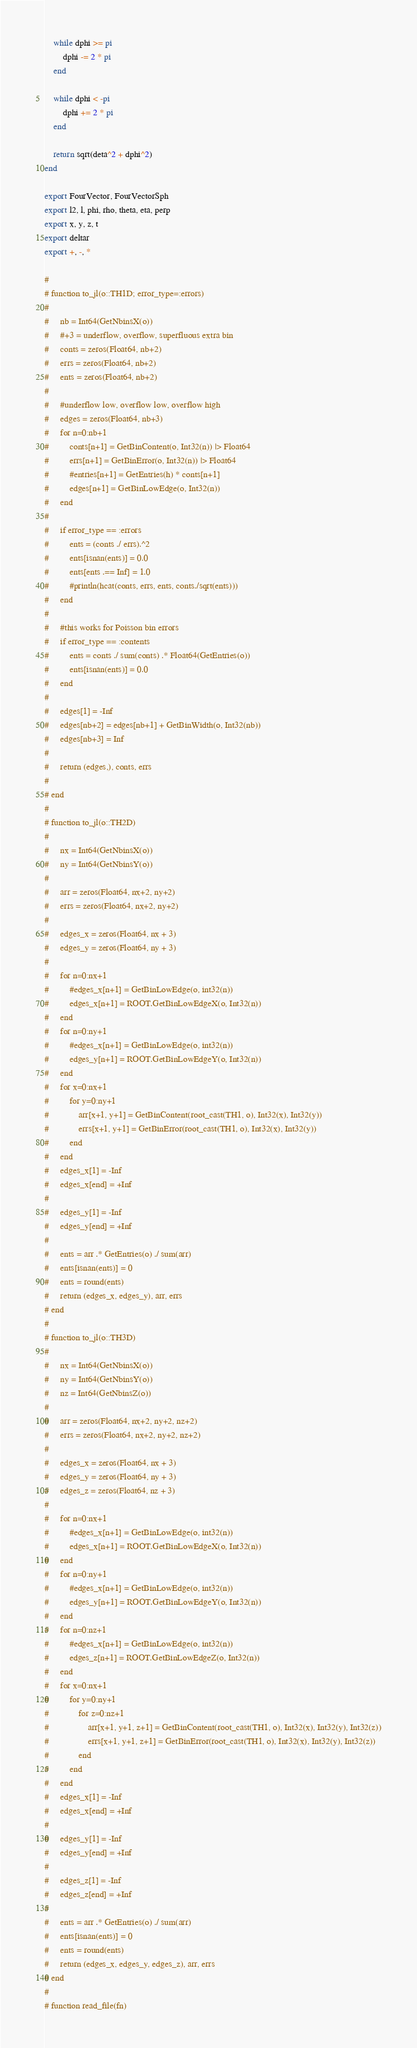Convert code to text. <code><loc_0><loc_0><loc_500><loc_500><_Julia_>    while dphi >= pi
        dphi -= 2 * pi
    end
    
    while dphi < -pi 
        dphi += 2 * pi
    end

    return sqrt(deta^2 + dphi^2)
end

export FourVector, FourVectorSph
export l2, l, phi, rho, theta, eta, perp
export x, y, z, t
export deltar
export +, -, *

# 
# function to_jl(o::TH1D; error_type=:errors)
#     
#     nb = Int64(GetNbinsX(o))
#     #+3 = underflow, overflow, superfluous extra bin
#     conts = zeros(Float64, nb+2)
#     errs = zeros(Float64, nb+2)
#     ents = zeros(Float64, nb+2)
# 
#     #underflow low, overflow low, overflow high
#     edges = zeros(Float64, nb+3)
#     for n=0:nb+1
#         conts[n+1] = GetBinContent(o, Int32(n)) |> Float64
#         errs[n+1] = GetBinError(o, Int32(n)) |> Float64
#         #entries[n+1] = GetEntries(h) * conts[n+1]
#         edges[n+1] = GetBinLowEdge(o, Int32(n))
#     end
#     
#     if error_type == :errors
#         ents = (conts ./ errs).^2
#         ents[isnan(ents)] = 0.0
#         ents[ents .== Inf] = 1.0
#         #println(hcat(conts, errs, ents, conts./sqrt(ents)))
#     end
# 
#     #this works for Poisson bin errors
#     if error_type == :contents
#         ents = conts ./ sum(conts) .* Float64(GetEntries(o))
#         ents[isnan(ents)] = 0.0
#     end
#     
#     edges[1] = -Inf
#     edges[nb+2] = edges[nb+1] + GetBinWidth(o, Int32(nb))
#     edges[nb+3] = Inf
#     
#     return (edges,), conts, errs
#     
# end
# 
# function to_jl(o::TH2D)
#     
#     nx = Int64(GetNbinsX(o))
#     ny = Int64(GetNbinsY(o))
#     
#     arr = zeros(Float64, nx+2, ny+2)
#     errs = zeros(Float64, nx+2, ny+2)
#     
#     edges_x = zeros(Float64, nx + 3)
#     edges_y = zeros(Float64, ny + 3)
#     
#     for n=0:nx+1
#         #edges_x[n+1] = GetBinLowEdge(o, int32(n))
#         edges_x[n+1] = ROOT.GetBinLowEdgeX(o, Int32(n))
#     end
#     for n=0:ny+1
#         #edges_x[n+1] = GetBinLowEdge(o, int32(n))
#         edges_y[n+1] = ROOT.GetBinLowEdgeY(o, Int32(n))
#     end
#     for x=0:nx+1
#         for y=0:ny+1
#             arr[x+1, y+1] = GetBinContent(root_cast(TH1, o), Int32(x), Int32(y))
#             errs[x+1, y+1] = GetBinError(root_cast(TH1, o), Int32(x), Int32(y))
#         end
#     end
#     edges_x[1] = -Inf
#     edges_x[end] = +Inf
# 
#     edges_y[1] = -Inf
#     edges_y[end] = +Inf
#     
#     ents = arr .* GetEntries(o) ./ sum(arr)
#     ents[isnan(ents)] = 0
#     ents = round(ents)
#     return (edges_x, edges_y), arr, errs
# end
# 
# function to_jl(o::TH3D)
#     
#     nx = Int64(GetNbinsX(o))
#     ny = Int64(GetNbinsY(o))
#     nz = Int64(GetNbinsZ(o))
#     
#     arr = zeros(Float64, nx+2, ny+2, nz+2)
#     errs = zeros(Float64, nx+2, ny+2, nz+2)
#     
#     edges_x = zeros(Float64, nx + 3)
#     edges_y = zeros(Float64, ny + 3)
#     edges_z = zeros(Float64, nz + 3)
#     
#     for n=0:nx+1
#         #edges_x[n+1] = GetBinLowEdge(o, int32(n))
#         edges_x[n+1] = ROOT.GetBinLowEdgeX(o, Int32(n))
#     end
#     for n=0:ny+1
#         #edges_x[n+1] = GetBinLowEdge(o, int32(n))
#         edges_y[n+1] = ROOT.GetBinLowEdgeY(o, Int32(n))
#     end
#     for n=0:nz+1
#         #edges_x[n+1] = GetBinLowEdge(o, int32(n))
#         edges_z[n+1] = ROOT.GetBinLowEdgeZ(o, Int32(n))
#     end
#     for x=0:nx+1
#         for y=0:ny+1
#             for z=0:nz+1
#                 arr[x+1, y+1, z+1] = GetBinContent(root_cast(TH1, o), Int32(x), Int32(y), Int32(z))
#                 errs[x+1, y+1, z+1] = GetBinError(root_cast(TH1, o), Int32(x), Int32(y), Int32(z))
#             end
#         end
#     end
#     edges_x[1] = -Inf
#     edges_x[end] = +Inf
# 
#     edges_y[1] = -Inf
#     edges_y[end] = +Inf
# 
#     edges_z[1] = -Inf
#     edges_z[end] = +Inf
#     
#     ents = arr .* GetEntries(o) ./ sum(arr)
#     ents[isnan(ents)] = 0
#     ents = round(ents)
#     return (edges_x, edges_y, edges_z), arr, errs
# end
# 
# function read_file(fn)</code> 